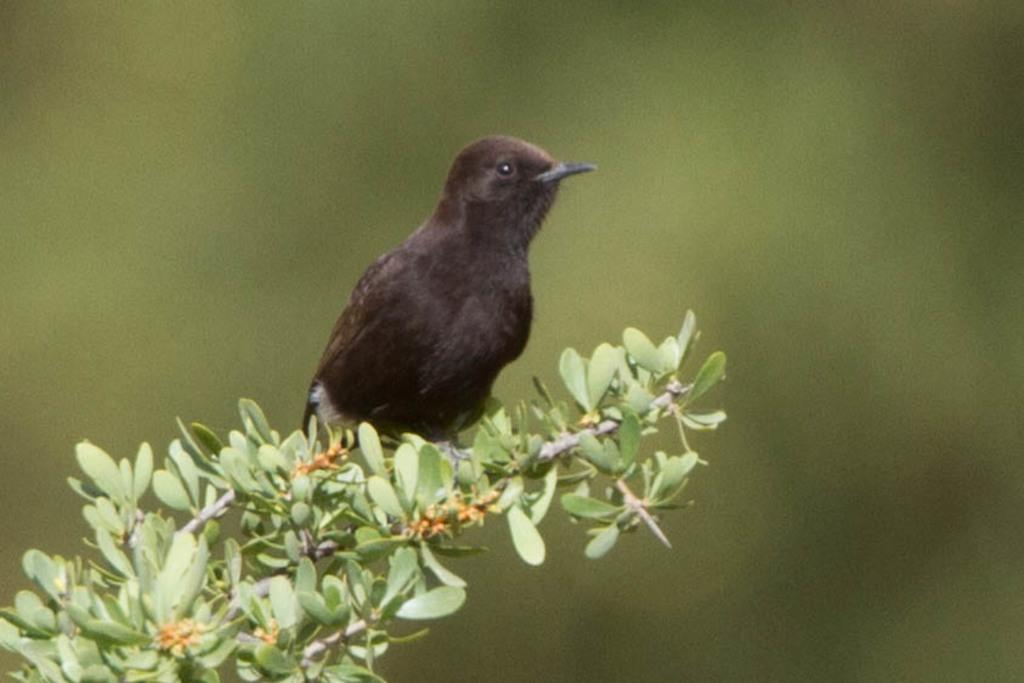What type of animal is in the image? There is a bird in the image. What color is the bird? The bird is black in color. Where is the bird located in the image? The bird is sitting on a plant. How would you describe the background of the image? The background of the image is blurred. What time does the clock show in the image? There is no clock present in the image, so it is not possible to determine the time. 